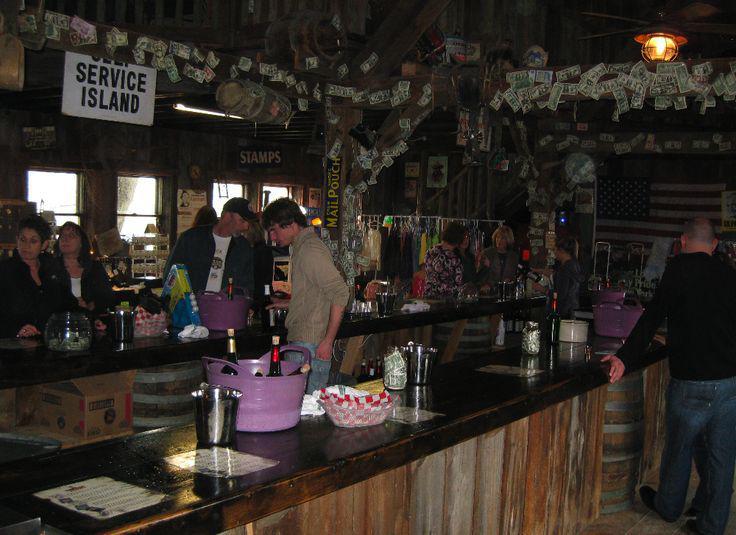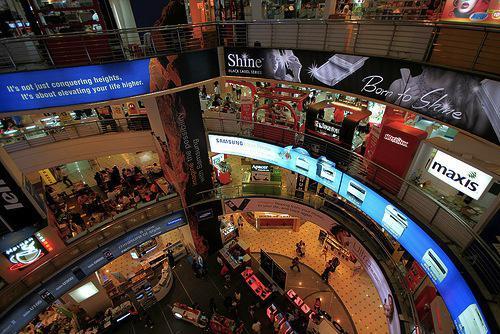The first image is the image on the left, the second image is the image on the right. Considering the images on both sides, is "In at least one image there are bar supplies on a wooden two tone bar with the top being dark brown." valid? Answer yes or no. Yes. 